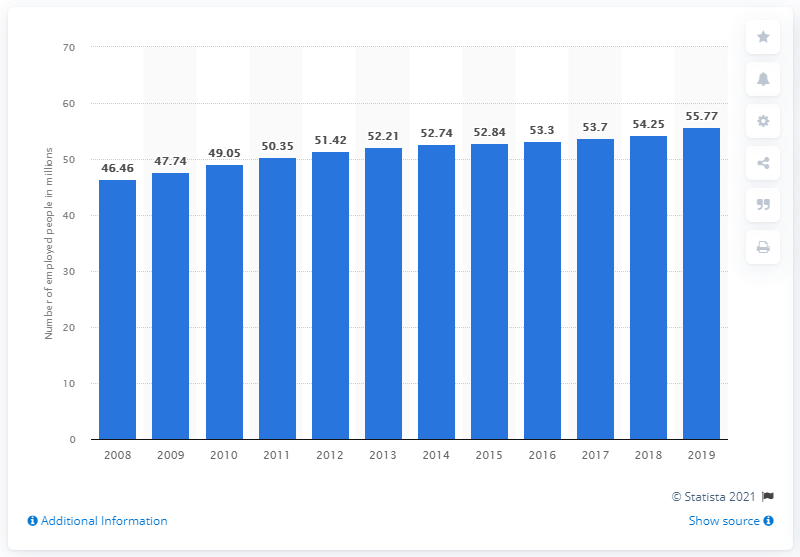List a handful of essential elements in this visual. In 2019, the number of people employed in Vietnam was approximately 55.77 million. 